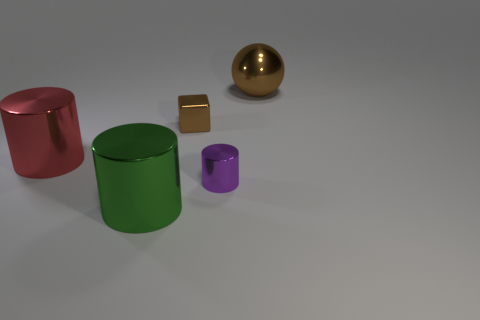Are there any other things that have the same material as the small cylinder?
Make the answer very short. Yes. What shape is the large thing that is the same color as the small cube?
Ensure brevity in your answer.  Sphere. The thing that is the same color as the small block is what size?
Offer a terse response. Large. Does the big object that is in front of the red metallic thing have the same shape as the red object?
Make the answer very short. Yes. How many other objects are the same shape as the large red metal thing?
Ensure brevity in your answer.  2. What shape is the big metal object on the right side of the green metal cylinder?
Provide a short and direct response. Sphere. Are there any big balls made of the same material as the large red cylinder?
Offer a very short reply. Yes. Do the small metallic object behind the big red shiny thing and the big metal sphere have the same color?
Keep it short and to the point. Yes. What is the size of the brown shiny sphere?
Provide a short and direct response. Large. There is a small thing that is behind the small metallic thing to the right of the metal cube; is there a brown shiny sphere left of it?
Keep it short and to the point. No. 